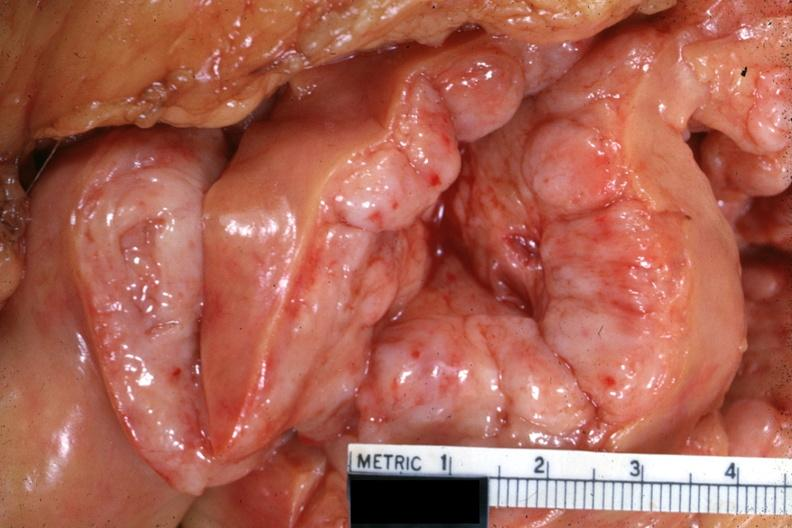what is present?
Answer the question using a single word or phrase. Malignant lymphoma large cell type 